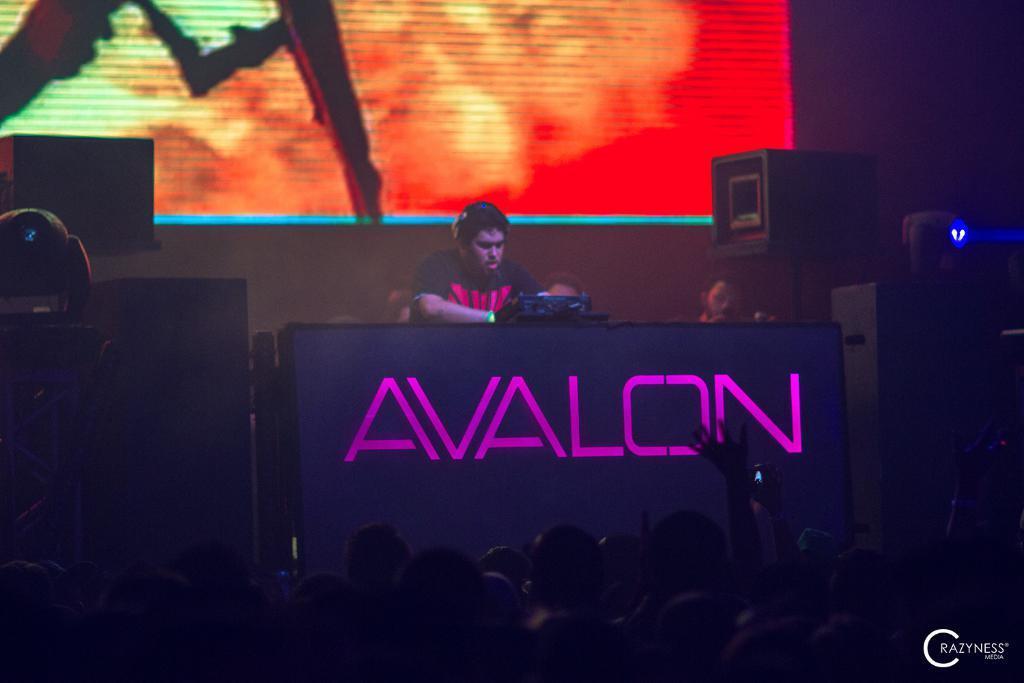In one or two sentences, can you explain what this image depicts? In the foreground of this image, there is a man standing near a podium with an electronic device. On bottom of the image, there is the crowd and on left and right side of the image, there are lights and in the background, there is a screen. 